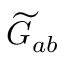<formula> <loc_0><loc_0><loc_500><loc_500>{ \widetilde { G } } _ { a b }</formula> 